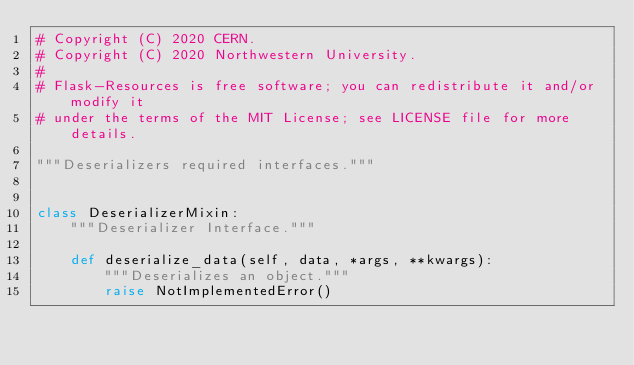<code> <loc_0><loc_0><loc_500><loc_500><_Python_># Copyright (C) 2020 CERN.
# Copyright (C) 2020 Northwestern University.
#
# Flask-Resources is free software; you can redistribute it and/or modify it
# under the terms of the MIT License; see LICENSE file for more details.

"""Deserializers required interfaces."""


class DeserializerMixin:
    """Deserializer Interface."""

    def deserialize_data(self, data, *args, **kwargs):
        """Deserializes an object."""
        raise NotImplementedError()
</code> 